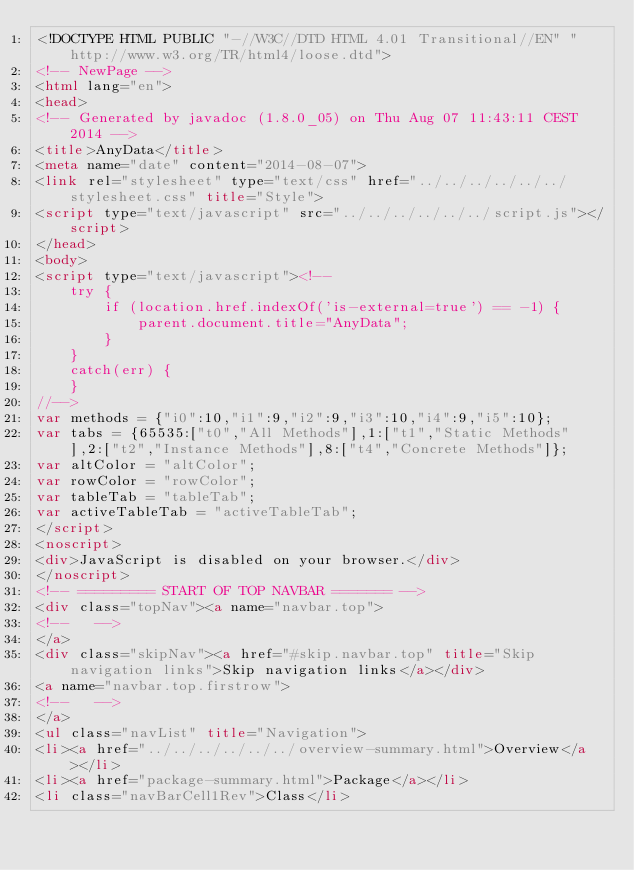<code> <loc_0><loc_0><loc_500><loc_500><_HTML_><!DOCTYPE HTML PUBLIC "-//W3C//DTD HTML 4.01 Transitional//EN" "http://www.w3.org/TR/html4/loose.dtd">
<!-- NewPage -->
<html lang="en">
<head>
<!-- Generated by javadoc (1.8.0_05) on Thu Aug 07 11:43:11 CEST 2014 -->
<title>AnyData</title>
<meta name="date" content="2014-08-07">
<link rel="stylesheet" type="text/css" href="../../../../../../stylesheet.css" title="Style">
<script type="text/javascript" src="../../../../../../script.js"></script>
</head>
<body>
<script type="text/javascript"><!--
    try {
        if (location.href.indexOf('is-external=true') == -1) {
            parent.document.title="AnyData";
        }
    }
    catch(err) {
    }
//-->
var methods = {"i0":10,"i1":9,"i2":9,"i3":10,"i4":9,"i5":10};
var tabs = {65535:["t0","All Methods"],1:["t1","Static Methods"],2:["t2","Instance Methods"],8:["t4","Concrete Methods"]};
var altColor = "altColor";
var rowColor = "rowColor";
var tableTab = "tableTab";
var activeTableTab = "activeTableTab";
</script>
<noscript>
<div>JavaScript is disabled on your browser.</div>
</noscript>
<!-- ========= START OF TOP NAVBAR ======= -->
<div class="topNav"><a name="navbar.top">
<!--   -->
</a>
<div class="skipNav"><a href="#skip.navbar.top" title="Skip navigation links">Skip navigation links</a></div>
<a name="navbar.top.firstrow">
<!--   -->
</a>
<ul class="navList" title="Navigation">
<li><a href="../../../../../../overview-summary.html">Overview</a></li>
<li><a href="package-summary.html">Package</a></li>
<li class="navBarCell1Rev">Class</li></code> 